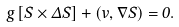<formula> <loc_0><loc_0><loc_500><loc_500>g \left [ \vec { S } \times \Delta \vec { S } \right ] + \left ( \vec { v } , \nabla \vec { S } \right ) = 0 .</formula> 